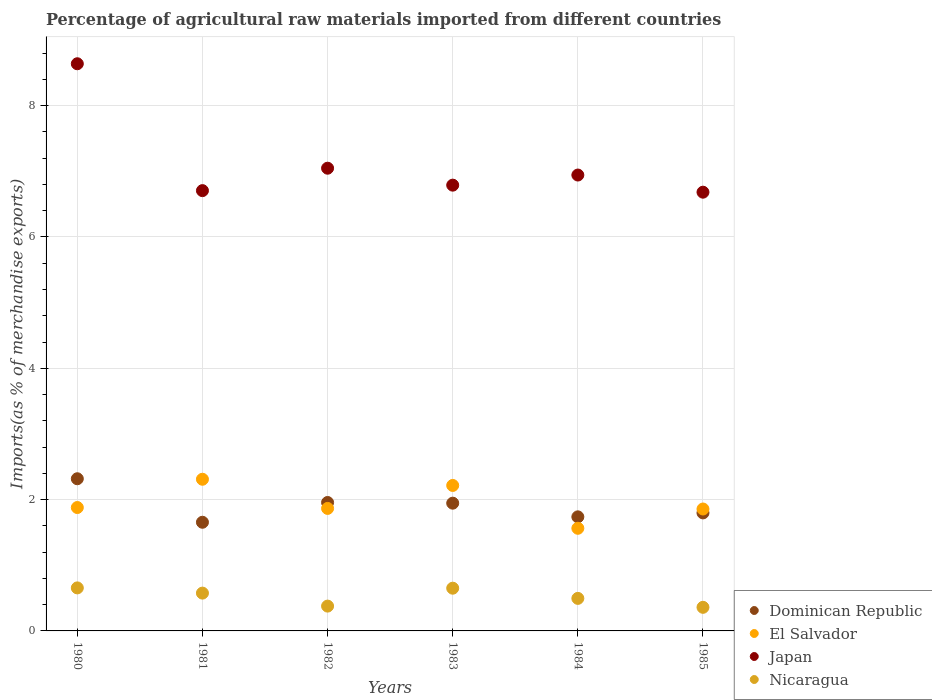Is the number of dotlines equal to the number of legend labels?
Provide a short and direct response. Yes. What is the percentage of imports to different countries in Japan in 1983?
Give a very brief answer. 6.79. Across all years, what is the maximum percentage of imports to different countries in Dominican Republic?
Offer a very short reply. 2.32. Across all years, what is the minimum percentage of imports to different countries in Nicaragua?
Make the answer very short. 0.36. What is the total percentage of imports to different countries in Japan in the graph?
Give a very brief answer. 42.8. What is the difference between the percentage of imports to different countries in El Salvador in 1982 and that in 1984?
Provide a short and direct response. 0.3. What is the difference between the percentage of imports to different countries in Nicaragua in 1983 and the percentage of imports to different countries in El Salvador in 1982?
Your response must be concise. -1.21. What is the average percentage of imports to different countries in Nicaragua per year?
Offer a terse response. 0.52. In the year 1981, what is the difference between the percentage of imports to different countries in El Salvador and percentage of imports to different countries in Dominican Republic?
Provide a succinct answer. 0.65. What is the ratio of the percentage of imports to different countries in Japan in 1981 to that in 1984?
Keep it short and to the point. 0.97. Is the percentage of imports to different countries in El Salvador in 1983 less than that in 1984?
Your answer should be very brief. No. Is the difference between the percentage of imports to different countries in El Salvador in 1980 and 1985 greater than the difference between the percentage of imports to different countries in Dominican Republic in 1980 and 1985?
Ensure brevity in your answer.  No. What is the difference between the highest and the second highest percentage of imports to different countries in Nicaragua?
Ensure brevity in your answer.  0. What is the difference between the highest and the lowest percentage of imports to different countries in Nicaragua?
Your response must be concise. 0.3. In how many years, is the percentage of imports to different countries in El Salvador greater than the average percentage of imports to different countries in El Salvador taken over all years?
Provide a succinct answer. 2. Is it the case that in every year, the sum of the percentage of imports to different countries in El Salvador and percentage of imports to different countries in Japan  is greater than the percentage of imports to different countries in Nicaragua?
Provide a succinct answer. Yes. Is the percentage of imports to different countries in Dominican Republic strictly less than the percentage of imports to different countries in Nicaragua over the years?
Offer a very short reply. No. How many dotlines are there?
Your answer should be very brief. 4. How many years are there in the graph?
Ensure brevity in your answer.  6. Does the graph contain any zero values?
Your answer should be compact. No. Where does the legend appear in the graph?
Your answer should be compact. Bottom right. How are the legend labels stacked?
Keep it short and to the point. Vertical. What is the title of the graph?
Provide a short and direct response. Percentage of agricultural raw materials imported from different countries. Does "High income: nonOECD" appear as one of the legend labels in the graph?
Keep it short and to the point. No. What is the label or title of the Y-axis?
Offer a terse response. Imports(as % of merchandise exports). What is the Imports(as % of merchandise exports) of Dominican Republic in 1980?
Provide a short and direct response. 2.32. What is the Imports(as % of merchandise exports) of El Salvador in 1980?
Offer a terse response. 1.88. What is the Imports(as % of merchandise exports) in Japan in 1980?
Ensure brevity in your answer.  8.64. What is the Imports(as % of merchandise exports) of Nicaragua in 1980?
Keep it short and to the point. 0.66. What is the Imports(as % of merchandise exports) of Dominican Republic in 1981?
Your answer should be compact. 1.65. What is the Imports(as % of merchandise exports) in El Salvador in 1981?
Provide a succinct answer. 2.31. What is the Imports(as % of merchandise exports) of Japan in 1981?
Your response must be concise. 6.71. What is the Imports(as % of merchandise exports) of Nicaragua in 1981?
Keep it short and to the point. 0.58. What is the Imports(as % of merchandise exports) in Dominican Republic in 1982?
Ensure brevity in your answer.  1.96. What is the Imports(as % of merchandise exports) of El Salvador in 1982?
Offer a very short reply. 1.87. What is the Imports(as % of merchandise exports) of Japan in 1982?
Your response must be concise. 7.05. What is the Imports(as % of merchandise exports) in Nicaragua in 1982?
Keep it short and to the point. 0.38. What is the Imports(as % of merchandise exports) in Dominican Republic in 1983?
Provide a short and direct response. 1.95. What is the Imports(as % of merchandise exports) in El Salvador in 1983?
Keep it short and to the point. 2.22. What is the Imports(as % of merchandise exports) of Japan in 1983?
Make the answer very short. 6.79. What is the Imports(as % of merchandise exports) in Nicaragua in 1983?
Your answer should be very brief. 0.65. What is the Imports(as % of merchandise exports) of Dominican Republic in 1984?
Provide a short and direct response. 1.74. What is the Imports(as % of merchandise exports) of El Salvador in 1984?
Your answer should be compact. 1.56. What is the Imports(as % of merchandise exports) in Japan in 1984?
Make the answer very short. 6.94. What is the Imports(as % of merchandise exports) in Nicaragua in 1984?
Your answer should be very brief. 0.5. What is the Imports(as % of merchandise exports) in Dominican Republic in 1985?
Provide a short and direct response. 1.8. What is the Imports(as % of merchandise exports) in El Salvador in 1985?
Your answer should be very brief. 1.86. What is the Imports(as % of merchandise exports) in Japan in 1985?
Give a very brief answer. 6.68. What is the Imports(as % of merchandise exports) of Nicaragua in 1985?
Offer a very short reply. 0.36. Across all years, what is the maximum Imports(as % of merchandise exports) in Dominican Republic?
Your answer should be very brief. 2.32. Across all years, what is the maximum Imports(as % of merchandise exports) of El Salvador?
Keep it short and to the point. 2.31. Across all years, what is the maximum Imports(as % of merchandise exports) of Japan?
Provide a succinct answer. 8.64. Across all years, what is the maximum Imports(as % of merchandise exports) of Nicaragua?
Keep it short and to the point. 0.66. Across all years, what is the minimum Imports(as % of merchandise exports) of Dominican Republic?
Your answer should be compact. 1.65. Across all years, what is the minimum Imports(as % of merchandise exports) in El Salvador?
Offer a terse response. 1.56. Across all years, what is the minimum Imports(as % of merchandise exports) of Japan?
Give a very brief answer. 6.68. Across all years, what is the minimum Imports(as % of merchandise exports) of Nicaragua?
Give a very brief answer. 0.36. What is the total Imports(as % of merchandise exports) of Dominican Republic in the graph?
Your answer should be very brief. 11.41. What is the total Imports(as % of merchandise exports) in El Salvador in the graph?
Your answer should be very brief. 11.69. What is the total Imports(as % of merchandise exports) of Japan in the graph?
Your response must be concise. 42.8. What is the total Imports(as % of merchandise exports) in Nicaragua in the graph?
Provide a succinct answer. 3.11. What is the difference between the Imports(as % of merchandise exports) of Dominican Republic in 1980 and that in 1981?
Provide a succinct answer. 0.66. What is the difference between the Imports(as % of merchandise exports) of El Salvador in 1980 and that in 1981?
Offer a very short reply. -0.43. What is the difference between the Imports(as % of merchandise exports) in Japan in 1980 and that in 1981?
Offer a very short reply. 1.93. What is the difference between the Imports(as % of merchandise exports) of Nicaragua in 1980 and that in 1981?
Your response must be concise. 0.08. What is the difference between the Imports(as % of merchandise exports) in Dominican Republic in 1980 and that in 1982?
Ensure brevity in your answer.  0.36. What is the difference between the Imports(as % of merchandise exports) of El Salvador in 1980 and that in 1982?
Offer a terse response. 0.01. What is the difference between the Imports(as % of merchandise exports) in Japan in 1980 and that in 1982?
Your answer should be very brief. 1.59. What is the difference between the Imports(as % of merchandise exports) in Nicaragua in 1980 and that in 1982?
Give a very brief answer. 0.28. What is the difference between the Imports(as % of merchandise exports) of Dominican Republic in 1980 and that in 1983?
Your answer should be very brief. 0.37. What is the difference between the Imports(as % of merchandise exports) in El Salvador in 1980 and that in 1983?
Offer a terse response. -0.34. What is the difference between the Imports(as % of merchandise exports) of Japan in 1980 and that in 1983?
Offer a very short reply. 1.85. What is the difference between the Imports(as % of merchandise exports) of Nicaragua in 1980 and that in 1983?
Your answer should be compact. 0. What is the difference between the Imports(as % of merchandise exports) of Dominican Republic in 1980 and that in 1984?
Your answer should be compact. 0.58. What is the difference between the Imports(as % of merchandise exports) of El Salvador in 1980 and that in 1984?
Give a very brief answer. 0.32. What is the difference between the Imports(as % of merchandise exports) of Japan in 1980 and that in 1984?
Provide a short and direct response. 1.69. What is the difference between the Imports(as % of merchandise exports) in Nicaragua in 1980 and that in 1984?
Your answer should be compact. 0.16. What is the difference between the Imports(as % of merchandise exports) of Dominican Republic in 1980 and that in 1985?
Offer a terse response. 0.52. What is the difference between the Imports(as % of merchandise exports) of El Salvador in 1980 and that in 1985?
Keep it short and to the point. 0.02. What is the difference between the Imports(as % of merchandise exports) of Japan in 1980 and that in 1985?
Your answer should be very brief. 1.96. What is the difference between the Imports(as % of merchandise exports) in Nicaragua in 1980 and that in 1985?
Provide a succinct answer. 0.3. What is the difference between the Imports(as % of merchandise exports) in Dominican Republic in 1981 and that in 1982?
Your answer should be compact. -0.3. What is the difference between the Imports(as % of merchandise exports) of El Salvador in 1981 and that in 1982?
Provide a succinct answer. 0.44. What is the difference between the Imports(as % of merchandise exports) in Japan in 1981 and that in 1982?
Provide a succinct answer. -0.34. What is the difference between the Imports(as % of merchandise exports) of Nicaragua in 1981 and that in 1982?
Give a very brief answer. 0.2. What is the difference between the Imports(as % of merchandise exports) of Dominican Republic in 1981 and that in 1983?
Offer a terse response. -0.29. What is the difference between the Imports(as % of merchandise exports) of El Salvador in 1981 and that in 1983?
Provide a short and direct response. 0.09. What is the difference between the Imports(as % of merchandise exports) in Japan in 1981 and that in 1983?
Your answer should be very brief. -0.08. What is the difference between the Imports(as % of merchandise exports) in Nicaragua in 1981 and that in 1983?
Your answer should be very brief. -0.07. What is the difference between the Imports(as % of merchandise exports) in Dominican Republic in 1981 and that in 1984?
Make the answer very short. -0.08. What is the difference between the Imports(as % of merchandise exports) of El Salvador in 1981 and that in 1984?
Ensure brevity in your answer.  0.75. What is the difference between the Imports(as % of merchandise exports) of Japan in 1981 and that in 1984?
Provide a succinct answer. -0.24. What is the difference between the Imports(as % of merchandise exports) of Nicaragua in 1981 and that in 1984?
Offer a terse response. 0.08. What is the difference between the Imports(as % of merchandise exports) in Dominican Republic in 1981 and that in 1985?
Your response must be concise. -0.14. What is the difference between the Imports(as % of merchandise exports) in El Salvador in 1981 and that in 1985?
Provide a short and direct response. 0.45. What is the difference between the Imports(as % of merchandise exports) in Japan in 1981 and that in 1985?
Provide a short and direct response. 0.02. What is the difference between the Imports(as % of merchandise exports) in Nicaragua in 1981 and that in 1985?
Make the answer very short. 0.22. What is the difference between the Imports(as % of merchandise exports) of Dominican Republic in 1982 and that in 1983?
Provide a succinct answer. 0.01. What is the difference between the Imports(as % of merchandise exports) in El Salvador in 1982 and that in 1983?
Give a very brief answer. -0.35. What is the difference between the Imports(as % of merchandise exports) in Japan in 1982 and that in 1983?
Make the answer very short. 0.26. What is the difference between the Imports(as % of merchandise exports) in Nicaragua in 1982 and that in 1983?
Offer a very short reply. -0.27. What is the difference between the Imports(as % of merchandise exports) in Dominican Republic in 1982 and that in 1984?
Your response must be concise. 0.22. What is the difference between the Imports(as % of merchandise exports) in El Salvador in 1982 and that in 1984?
Your response must be concise. 0.3. What is the difference between the Imports(as % of merchandise exports) of Japan in 1982 and that in 1984?
Offer a very short reply. 0.1. What is the difference between the Imports(as % of merchandise exports) of Nicaragua in 1982 and that in 1984?
Keep it short and to the point. -0.12. What is the difference between the Imports(as % of merchandise exports) of Dominican Republic in 1982 and that in 1985?
Your answer should be very brief. 0.16. What is the difference between the Imports(as % of merchandise exports) of El Salvador in 1982 and that in 1985?
Make the answer very short. 0.01. What is the difference between the Imports(as % of merchandise exports) of Japan in 1982 and that in 1985?
Your answer should be compact. 0.37. What is the difference between the Imports(as % of merchandise exports) of Nicaragua in 1982 and that in 1985?
Your answer should be compact. 0.02. What is the difference between the Imports(as % of merchandise exports) of Dominican Republic in 1983 and that in 1984?
Offer a very short reply. 0.21. What is the difference between the Imports(as % of merchandise exports) of El Salvador in 1983 and that in 1984?
Offer a terse response. 0.65. What is the difference between the Imports(as % of merchandise exports) in Japan in 1983 and that in 1984?
Provide a succinct answer. -0.15. What is the difference between the Imports(as % of merchandise exports) of Nicaragua in 1983 and that in 1984?
Your answer should be very brief. 0.16. What is the difference between the Imports(as % of merchandise exports) of Dominican Republic in 1983 and that in 1985?
Give a very brief answer. 0.15. What is the difference between the Imports(as % of merchandise exports) of El Salvador in 1983 and that in 1985?
Offer a terse response. 0.36. What is the difference between the Imports(as % of merchandise exports) in Japan in 1983 and that in 1985?
Provide a short and direct response. 0.11. What is the difference between the Imports(as % of merchandise exports) in Nicaragua in 1983 and that in 1985?
Give a very brief answer. 0.29. What is the difference between the Imports(as % of merchandise exports) of Dominican Republic in 1984 and that in 1985?
Keep it short and to the point. -0.06. What is the difference between the Imports(as % of merchandise exports) of El Salvador in 1984 and that in 1985?
Provide a succinct answer. -0.29. What is the difference between the Imports(as % of merchandise exports) in Japan in 1984 and that in 1985?
Your answer should be very brief. 0.26. What is the difference between the Imports(as % of merchandise exports) of Nicaragua in 1984 and that in 1985?
Your answer should be compact. 0.14. What is the difference between the Imports(as % of merchandise exports) in Dominican Republic in 1980 and the Imports(as % of merchandise exports) in El Salvador in 1981?
Keep it short and to the point. 0.01. What is the difference between the Imports(as % of merchandise exports) in Dominican Republic in 1980 and the Imports(as % of merchandise exports) in Japan in 1981?
Make the answer very short. -4.39. What is the difference between the Imports(as % of merchandise exports) of Dominican Republic in 1980 and the Imports(as % of merchandise exports) of Nicaragua in 1981?
Provide a short and direct response. 1.74. What is the difference between the Imports(as % of merchandise exports) of El Salvador in 1980 and the Imports(as % of merchandise exports) of Japan in 1981?
Make the answer very short. -4.83. What is the difference between the Imports(as % of merchandise exports) in El Salvador in 1980 and the Imports(as % of merchandise exports) in Nicaragua in 1981?
Make the answer very short. 1.3. What is the difference between the Imports(as % of merchandise exports) in Japan in 1980 and the Imports(as % of merchandise exports) in Nicaragua in 1981?
Provide a succinct answer. 8.06. What is the difference between the Imports(as % of merchandise exports) in Dominican Republic in 1980 and the Imports(as % of merchandise exports) in El Salvador in 1982?
Provide a succinct answer. 0.45. What is the difference between the Imports(as % of merchandise exports) in Dominican Republic in 1980 and the Imports(as % of merchandise exports) in Japan in 1982?
Ensure brevity in your answer.  -4.73. What is the difference between the Imports(as % of merchandise exports) of Dominican Republic in 1980 and the Imports(as % of merchandise exports) of Nicaragua in 1982?
Keep it short and to the point. 1.94. What is the difference between the Imports(as % of merchandise exports) in El Salvador in 1980 and the Imports(as % of merchandise exports) in Japan in 1982?
Offer a very short reply. -5.17. What is the difference between the Imports(as % of merchandise exports) in El Salvador in 1980 and the Imports(as % of merchandise exports) in Nicaragua in 1982?
Your response must be concise. 1.5. What is the difference between the Imports(as % of merchandise exports) of Japan in 1980 and the Imports(as % of merchandise exports) of Nicaragua in 1982?
Offer a terse response. 8.26. What is the difference between the Imports(as % of merchandise exports) of Dominican Republic in 1980 and the Imports(as % of merchandise exports) of El Salvador in 1983?
Make the answer very short. 0.1. What is the difference between the Imports(as % of merchandise exports) in Dominican Republic in 1980 and the Imports(as % of merchandise exports) in Japan in 1983?
Provide a short and direct response. -4.47. What is the difference between the Imports(as % of merchandise exports) in Dominican Republic in 1980 and the Imports(as % of merchandise exports) in Nicaragua in 1983?
Give a very brief answer. 1.67. What is the difference between the Imports(as % of merchandise exports) in El Salvador in 1980 and the Imports(as % of merchandise exports) in Japan in 1983?
Your response must be concise. -4.91. What is the difference between the Imports(as % of merchandise exports) in El Salvador in 1980 and the Imports(as % of merchandise exports) in Nicaragua in 1983?
Provide a succinct answer. 1.23. What is the difference between the Imports(as % of merchandise exports) of Japan in 1980 and the Imports(as % of merchandise exports) of Nicaragua in 1983?
Give a very brief answer. 7.99. What is the difference between the Imports(as % of merchandise exports) of Dominican Republic in 1980 and the Imports(as % of merchandise exports) of El Salvador in 1984?
Ensure brevity in your answer.  0.75. What is the difference between the Imports(as % of merchandise exports) in Dominican Republic in 1980 and the Imports(as % of merchandise exports) in Japan in 1984?
Provide a short and direct response. -4.63. What is the difference between the Imports(as % of merchandise exports) in Dominican Republic in 1980 and the Imports(as % of merchandise exports) in Nicaragua in 1984?
Your response must be concise. 1.82. What is the difference between the Imports(as % of merchandise exports) of El Salvador in 1980 and the Imports(as % of merchandise exports) of Japan in 1984?
Offer a very short reply. -5.06. What is the difference between the Imports(as % of merchandise exports) of El Salvador in 1980 and the Imports(as % of merchandise exports) of Nicaragua in 1984?
Provide a succinct answer. 1.38. What is the difference between the Imports(as % of merchandise exports) in Japan in 1980 and the Imports(as % of merchandise exports) in Nicaragua in 1984?
Make the answer very short. 8.14. What is the difference between the Imports(as % of merchandise exports) in Dominican Republic in 1980 and the Imports(as % of merchandise exports) in El Salvador in 1985?
Ensure brevity in your answer.  0.46. What is the difference between the Imports(as % of merchandise exports) in Dominican Republic in 1980 and the Imports(as % of merchandise exports) in Japan in 1985?
Provide a succinct answer. -4.36. What is the difference between the Imports(as % of merchandise exports) in Dominican Republic in 1980 and the Imports(as % of merchandise exports) in Nicaragua in 1985?
Keep it short and to the point. 1.96. What is the difference between the Imports(as % of merchandise exports) of El Salvador in 1980 and the Imports(as % of merchandise exports) of Japan in 1985?
Provide a short and direct response. -4.8. What is the difference between the Imports(as % of merchandise exports) in El Salvador in 1980 and the Imports(as % of merchandise exports) in Nicaragua in 1985?
Your response must be concise. 1.52. What is the difference between the Imports(as % of merchandise exports) in Japan in 1980 and the Imports(as % of merchandise exports) in Nicaragua in 1985?
Your answer should be compact. 8.28. What is the difference between the Imports(as % of merchandise exports) in Dominican Republic in 1981 and the Imports(as % of merchandise exports) in El Salvador in 1982?
Make the answer very short. -0.21. What is the difference between the Imports(as % of merchandise exports) of Dominican Republic in 1981 and the Imports(as % of merchandise exports) of Japan in 1982?
Offer a very short reply. -5.39. What is the difference between the Imports(as % of merchandise exports) in Dominican Republic in 1981 and the Imports(as % of merchandise exports) in Nicaragua in 1982?
Provide a succinct answer. 1.28. What is the difference between the Imports(as % of merchandise exports) of El Salvador in 1981 and the Imports(as % of merchandise exports) of Japan in 1982?
Your answer should be very brief. -4.74. What is the difference between the Imports(as % of merchandise exports) in El Salvador in 1981 and the Imports(as % of merchandise exports) in Nicaragua in 1982?
Provide a succinct answer. 1.93. What is the difference between the Imports(as % of merchandise exports) of Japan in 1981 and the Imports(as % of merchandise exports) of Nicaragua in 1982?
Your answer should be very brief. 6.33. What is the difference between the Imports(as % of merchandise exports) of Dominican Republic in 1981 and the Imports(as % of merchandise exports) of El Salvador in 1983?
Provide a succinct answer. -0.56. What is the difference between the Imports(as % of merchandise exports) in Dominican Republic in 1981 and the Imports(as % of merchandise exports) in Japan in 1983?
Make the answer very short. -5.13. What is the difference between the Imports(as % of merchandise exports) in El Salvador in 1981 and the Imports(as % of merchandise exports) in Japan in 1983?
Your response must be concise. -4.48. What is the difference between the Imports(as % of merchandise exports) in El Salvador in 1981 and the Imports(as % of merchandise exports) in Nicaragua in 1983?
Your response must be concise. 1.66. What is the difference between the Imports(as % of merchandise exports) in Japan in 1981 and the Imports(as % of merchandise exports) in Nicaragua in 1983?
Give a very brief answer. 6.05. What is the difference between the Imports(as % of merchandise exports) in Dominican Republic in 1981 and the Imports(as % of merchandise exports) in El Salvador in 1984?
Provide a succinct answer. 0.09. What is the difference between the Imports(as % of merchandise exports) in Dominican Republic in 1981 and the Imports(as % of merchandise exports) in Japan in 1984?
Your answer should be compact. -5.29. What is the difference between the Imports(as % of merchandise exports) in Dominican Republic in 1981 and the Imports(as % of merchandise exports) in Nicaragua in 1984?
Your answer should be compact. 1.16. What is the difference between the Imports(as % of merchandise exports) in El Salvador in 1981 and the Imports(as % of merchandise exports) in Japan in 1984?
Offer a very short reply. -4.63. What is the difference between the Imports(as % of merchandise exports) in El Salvador in 1981 and the Imports(as % of merchandise exports) in Nicaragua in 1984?
Give a very brief answer. 1.81. What is the difference between the Imports(as % of merchandise exports) in Japan in 1981 and the Imports(as % of merchandise exports) in Nicaragua in 1984?
Your answer should be compact. 6.21. What is the difference between the Imports(as % of merchandise exports) of Dominican Republic in 1981 and the Imports(as % of merchandise exports) of El Salvador in 1985?
Your answer should be compact. -0.2. What is the difference between the Imports(as % of merchandise exports) of Dominican Republic in 1981 and the Imports(as % of merchandise exports) of Japan in 1985?
Provide a succinct answer. -5.03. What is the difference between the Imports(as % of merchandise exports) of Dominican Republic in 1981 and the Imports(as % of merchandise exports) of Nicaragua in 1985?
Your response must be concise. 1.3. What is the difference between the Imports(as % of merchandise exports) in El Salvador in 1981 and the Imports(as % of merchandise exports) in Japan in 1985?
Give a very brief answer. -4.37. What is the difference between the Imports(as % of merchandise exports) of El Salvador in 1981 and the Imports(as % of merchandise exports) of Nicaragua in 1985?
Your response must be concise. 1.95. What is the difference between the Imports(as % of merchandise exports) in Japan in 1981 and the Imports(as % of merchandise exports) in Nicaragua in 1985?
Your response must be concise. 6.35. What is the difference between the Imports(as % of merchandise exports) of Dominican Republic in 1982 and the Imports(as % of merchandise exports) of El Salvador in 1983?
Your answer should be compact. -0.26. What is the difference between the Imports(as % of merchandise exports) of Dominican Republic in 1982 and the Imports(as % of merchandise exports) of Japan in 1983?
Make the answer very short. -4.83. What is the difference between the Imports(as % of merchandise exports) of Dominican Republic in 1982 and the Imports(as % of merchandise exports) of Nicaragua in 1983?
Ensure brevity in your answer.  1.31. What is the difference between the Imports(as % of merchandise exports) in El Salvador in 1982 and the Imports(as % of merchandise exports) in Japan in 1983?
Offer a terse response. -4.92. What is the difference between the Imports(as % of merchandise exports) in El Salvador in 1982 and the Imports(as % of merchandise exports) in Nicaragua in 1983?
Make the answer very short. 1.21. What is the difference between the Imports(as % of merchandise exports) in Japan in 1982 and the Imports(as % of merchandise exports) in Nicaragua in 1983?
Your response must be concise. 6.4. What is the difference between the Imports(as % of merchandise exports) of Dominican Republic in 1982 and the Imports(as % of merchandise exports) of El Salvador in 1984?
Your answer should be very brief. 0.39. What is the difference between the Imports(as % of merchandise exports) in Dominican Republic in 1982 and the Imports(as % of merchandise exports) in Japan in 1984?
Make the answer very short. -4.99. What is the difference between the Imports(as % of merchandise exports) of Dominican Republic in 1982 and the Imports(as % of merchandise exports) of Nicaragua in 1984?
Offer a very short reply. 1.46. What is the difference between the Imports(as % of merchandise exports) of El Salvador in 1982 and the Imports(as % of merchandise exports) of Japan in 1984?
Provide a short and direct response. -5.08. What is the difference between the Imports(as % of merchandise exports) of El Salvador in 1982 and the Imports(as % of merchandise exports) of Nicaragua in 1984?
Offer a terse response. 1.37. What is the difference between the Imports(as % of merchandise exports) of Japan in 1982 and the Imports(as % of merchandise exports) of Nicaragua in 1984?
Offer a terse response. 6.55. What is the difference between the Imports(as % of merchandise exports) in Dominican Republic in 1982 and the Imports(as % of merchandise exports) in El Salvador in 1985?
Offer a very short reply. 0.1. What is the difference between the Imports(as % of merchandise exports) in Dominican Republic in 1982 and the Imports(as % of merchandise exports) in Japan in 1985?
Your response must be concise. -4.73. What is the difference between the Imports(as % of merchandise exports) of Dominican Republic in 1982 and the Imports(as % of merchandise exports) of Nicaragua in 1985?
Provide a short and direct response. 1.6. What is the difference between the Imports(as % of merchandise exports) in El Salvador in 1982 and the Imports(as % of merchandise exports) in Japan in 1985?
Keep it short and to the point. -4.82. What is the difference between the Imports(as % of merchandise exports) of El Salvador in 1982 and the Imports(as % of merchandise exports) of Nicaragua in 1985?
Your answer should be compact. 1.51. What is the difference between the Imports(as % of merchandise exports) of Japan in 1982 and the Imports(as % of merchandise exports) of Nicaragua in 1985?
Give a very brief answer. 6.69. What is the difference between the Imports(as % of merchandise exports) in Dominican Republic in 1983 and the Imports(as % of merchandise exports) in El Salvador in 1984?
Your answer should be very brief. 0.38. What is the difference between the Imports(as % of merchandise exports) in Dominican Republic in 1983 and the Imports(as % of merchandise exports) in Japan in 1984?
Your answer should be very brief. -5. What is the difference between the Imports(as % of merchandise exports) in Dominican Republic in 1983 and the Imports(as % of merchandise exports) in Nicaragua in 1984?
Your answer should be very brief. 1.45. What is the difference between the Imports(as % of merchandise exports) of El Salvador in 1983 and the Imports(as % of merchandise exports) of Japan in 1984?
Your response must be concise. -4.73. What is the difference between the Imports(as % of merchandise exports) of El Salvador in 1983 and the Imports(as % of merchandise exports) of Nicaragua in 1984?
Offer a terse response. 1.72. What is the difference between the Imports(as % of merchandise exports) of Japan in 1983 and the Imports(as % of merchandise exports) of Nicaragua in 1984?
Ensure brevity in your answer.  6.29. What is the difference between the Imports(as % of merchandise exports) of Dominican Republic in 1983 and the Imports(as % of merchandise exports) of El Salvador in 1985?
Offer a terse response. 0.09. What is the difference between the Imports(as % of merchandise exports) of Dominican Republic in 1983 and the Imports(as % of merchandise exports) of Japan in 1985?
Offer a terse response. -4.74. What is the difference between the Imports(as % of merchandise exports) of Dominican Republic in 1983 and the Imports(as % of merchandise exports) of Nicaragua in 1985?
Your answer should be compact. 1.59. What is the difference between the Imports(as % of merchandise exports) in El Salvador in 1983 and the Imports(as % of merchandise exports) in Japan in 1985?
Offer a very short reply. -4.47. What is the difference between the Imports(as % of merchandise exports) in El Salvador in 1983 and the Imports(as % of merchandise exports) in Nicaragua in 1985?
Ensure brevity in your answer.  1.86. What is the difference between the Imports(as % of merchandise exports) in Japan in 1983 and the Imports(as % of merchandise exports) in Nicaragua in 1985?
Offer a very short reply. 6.43. What is the difference between the Imports(as % of merchandise exports) in Dominican Republic in 1984 and the Imports(as % of merchandise exports) in El Salvador in 1985?
Give a very brief answer. -0.12. What is the difference between the Imports(as % of merchandise exports) in Dominican Republic in 1984 and the Imports(as % of merchandise exports) in Japan in 1985?
Offer a very short reply. -4.94. What is the difference between the Imports(as % of merchandise exports) of Dominican Republic in 1984 and the Imports(as % of merchandise exports) of Nicaragua in 1985?
Offer a very short reply. 1.38. What is the difference between the Imports(as % of merchandise exports) of El Salvador in 1984 and the Imports(as % of merchandise exports) of Japan in 1985?
Keep it short and to the point. -5.12. What is the difference between the Imports(as % of merchandise exports) of El Salvador in 1984 and the Imports(as % of merchandise exports) of Nicaragua in 1985?
Provide a succinct answer. 1.2. What is the difference between the Imports(as % of merchandise exports) of Japan in 1984 and the Imports(as % of merchandise exports) of Nicaragua in 1985?
Keep it short and to the point. 6.58. What is the average Imports(as % of merchandise exports) of Dominican Republic per year?
Your answer should be compact. 1.9. What is the average Imports(as % of merchandise exports) in El Salvador per year?
Provide a succinct answer. 1.95. What is the average Imports(as % of merchandise exports) in Japan per year?
Offer a very short reply. 7.13. What is the average Imports(as % of merchandise exports) of Nicaragua per year?
Offer a terse response. 0.52. In the year 1980, what is the difference between the Imports(as % of merchandise exports) of Dominican Republic and Imports(as % of merchandise exports) of El Salvador?
Keep it short and to the point. 0.44. In the year 1980, what is the difference between the Imports(as % of merchandise exports) of Dominican Republic and Imports(as % of merchandise exports) of Japan?
Give a very brief answer. -6.32. In the year 1980, what is the difference between the Imports(as % of merchandise exports) of Dominican Republic and Imports(as % of merchandise exports) of Nicaragua?
Ensure brevity in your answer.  1.66. In the year 1980, what is the difference between the Imports(as % of merchandise exports) of El Salvador and Imports(as % of merchandise exports) of Japan?
Make the answer very short. -6.76. In the year 1980, what is the difference between the Imports(as % of merchandise exports) in El Salvador and Imports(as % of merchandise exports) in Nicaragua?
Make the answer very short. 1.22. In the year 1980, what is the difference between the Imports(as % of merchandise exports) in Japan and Imports(as % of merchandise exports) in Nicaragua?
Offer a terse response. 7.98. In the year 1981, what is the difference between the Imports(as % of merchandise exports) of Dominican Republic and Imports(as % of merchandise exports) of El Salvador?
Offer a terse response. -0.66. In the year 1981, what is the difference between the Imports(as % of merchandise exports) in Dominican Republic and Imports(as % of merchandise exports) in Japan?
Provide a succinct answer. -5.05. In the year 1981, what is the difference between the Imports(as % of merchandise exports) of Dominican Republic and Imports(as % of merchandise exports) of Nicaragua?
Make the answer very short. 1.08. In the year 1981, what is the difference between the Imports(as % of merchandise exports) in El Salvador and Imports(as % of merchandise exports) in Japan?
Make the answer very short. -4.4. In the year 1981, what is the difference between the Imports(as % of merchandise exports) of El Salvador and Imports(as % of merchandise exports) of Nicaragua?
Provide a short and direct response. 1.73. In the year 1981, what is the difference between the Imports(as % of merchandise exports) of Japan and Imports(as % of merchandise exports) of Nicaragua?
Your answer should be compact. 6.13. In the year 1982, what is the difference between the Imports(as % of merchandise exports) in Dominican Republic and Imports(as % of merchandise exports) in El Salvador?
Offer a very short reply. 0.09. In the year 1982, what is the difference between the Imports(as % of merchandise exports) in Dominican Republic and Imports(as % of merchandise exports) in Japan?
Your answer should be compact. -5.09. In the year 1982, what is the difference between the Imports(as % of merchandise exports) in Dominican Republic and Imports(as % of merchandise exports) in Nicaragua?
Provide a succinct answer. 1.58. In the year 1982, what is the difference between the Imports(as % of merchandise exports) of El Salvador and Imports(as % of merchandise exports) of Japan?
Ensure brevity in your answer.  -5.18. In the year 1982, what is the difference between the Imports(as % of merchandise exports) in El Salvador and Imports(as % of merchandise exports) in Nicaragua?
Make the answer very short. 1.49. In the year 1982, what is the difference between the Imports(as % of merchandise exports) of Japan and Imports(as % of merchandise exports) of Nicaragua?
Your response must be concise. 6.67. In the year 1983, what is the difference between the Imports(as % of merchandise exports) in Dominican Republic and Imports(as % of merchandise exports) in El Salvador?
Offer a very short reply. -0.27. In the year 1983, what is the difference between the Imports(as % of merchandise exports) in Dominican Republic and Imports(as % of merchandise exports) in Japan?
Make the answer very short. -4.84. In the year 1983, what is the difference between the Imports(as % of merchandise exports) in Dominican Republic and Imports(as % of merchandise exports) in Nicaragua?
Your response must be concise. 1.29. In the year 1983, what is the difference between the Imports(as % of merchandise exports) in El Salvador and Imports(as % of merchandise exports) in Japan?
Keep it short and to the point. -4.57. In the year 1983, what is the difference between the Imports(as % of merchandise exports) of El Salvador and Imports(as % of merchandise exports) of Nicaragua?
Ensure brevity in your answer.  1.56. In the year 1983, what is the difference between the Imports(as % of merchandise exports) of Japan and Imports(as % of merchandise exports) of Nicaragua?
Your answer should be very brief. 6.14. In the year 1984, what is the difference between the Imports(as % of merchandise exports) in Dominican Republic and Imports(as % of merchandise exports) in El Salvador?
Provide a short and direct response. 0.17. In the year 1984, what is the difference between the Imports(as % of merchandise exports) of Dominican Republic and Imports(as % of merchandise exports) of Japan?
Offer a very short reply. -5.21. In the year 1984, what is the difference between the Imports(as % of merchandise exports) of Dominican Republic and Imports(as % of merchandise exports) of Nicaragua?
Offer a very short reply. 1.24. In the year 1984, what is the difference between the Imports(as % of merchandise exports) of El Salvador and Imports(as % of merchandise exports) of Japan?
Your response must be concise. -5.38. In the year 1984, what is the difference between the Imports(as % of merchandise exports) of El Salvador and Imports(as % of merchandise exports) of Nicaragua?
Keep it short and to the point. 1.07. In the year 1984, what is the difference between the Imports(as % of merchandise exports) in Japan and Imports(as % of merchandise exports) in Nicaragua?
Ensure brevity in your answer.  6.45. In the year 1985, what is the difference between the Imports(as % of merchandise exports) in Dominican Republic and Imports(as % of merchandise exports) in El Salvador?
Offer a terse response. -0.06. In the year 1985, what is the difference between the Imports(as % of merchandise exports) in Dominican Republic and Imports(as % of merchandise exports) in Japan?
Give a very brief answer. -4.88. In the year 1985, what is the difference between the Imports(as % of merchandise exports) of Dominican Republic and Imports(as % of merchandise exports) of Nicaragua?
Make the answer very short. 1.44. In the year 1985, what is the difference between the Imports(as % of merchandise exports) in El Salvador and Imports(as % of merchandise exports) in Japan?
Offer a terse response. -4.82. In the year 1985, what is the difference between the Imports(as % of merchandise exports) in El Salvador and Imports(as % of merchandise exports) in Nicaragua?
Give a very brief answer. 1.5. In the year 1985, what is the difference between the Imports(as % of merchandise exports) of Japan and Imports(as % of merchandise exports) of Nicaragua?
Offer a terse response. 6.32. What is the ratio of the Imports(as % of merchandise exports) of Dominican Republic in 1980 to that in 1981?
Provide a short and direct response. 1.4. What is the ratio of the Imports(as % of merchandise exports) of El Salvador in 1980 to that in 1981?
Your answer should be very brief. 0.81. What is the ratio of the Imports(as % of merchandise exports) in Japan in 1980 to that in 1981?
Ensure brevity in your answer.  1.29. What is the ratio of the Imports(as % of merchandise exports) in Nicaragua in 1980 to that in 1981?
Give a very brief answer. 1.14. What is the ratio of the Imports(as % of merchandise exports) in Dominican Republic in 1980 to that in 1982?
Provide a short and direct response. 1.18. What is the ratio of the Imports(as % of merchandise exports) of El Salvador in 1980 to that in 1982?
Give a very brief answer. 1.01. What is the ratio of the Imports(as % of merchandise exports) of Japan in 1980 to that in 1982?
Your response must be concise. 1.23. What is the ratio of the Imports(as % of merchandise exports) of Nicaragua in 1980 to that in 1982?
Offer a very short reply. 1.73. What is the ratio of the Imports(as % of merchandise exports) of Dominican Republic in 1980 to that in 1983?
Give a very brief answer. 1.19. What is the ratio of the Imports(as % of merchandise exports) of El Salvador in 1980 to that in 1983?
Provide a short and direct response. 0.85. What is the ratio of the Imports(as % of merchandise exports) of Japan in 1980 to that in 1983?
Your response must be concise. 1.27. What is the ratio of the Imports(as % of merchandise exports) of Nicaragua in 1980 to that in 1983?
Ensure brevity in your answer.  1.01. What is the ratio of the Imports(as % of merchandise exports) of Dominican Republic in 1980 to that in 1984?
Ensure brevity in your answer.  1.33. What is the ratio of the Imports(as % of merchandise exports) in El Salvador in 1980 to that in 1984?
Provide a succinct answer. 1.2. What is the ratio of the Imports(as % of merchandise exports) in Japan in 1980 to that in 1984?
Offer a very short reply. 1.24. What is the ratio of the Imports(as % of merchandise exports) in Nicaragua in 1980 to that in 1984?
Provide a short and direct response. 1.32. What is the ratio of the Imports(as % of merchandise exports) in Dominican Republic in 1980 to that in 1985?
Your answer should be very brief. 1.29. What is the ratio of the Imports(as % of merchandise exports) of El Salvador in 1980 to that in 1985?
Your answer should be very brief. 1.01. What is the ratio of the Imports(as % of merchandise exports) in Japan in 1980 to that in 1985?
Ensure brevity in your answer.  1.29. What is the ratio of the Imports(as % of merchandise exports) in Nicaragua in 1980 to that in 1985?
Offer a terse response. 1.82. What is the ratio of the Imports(as % of merchandise exports) of Dominican Republic in 1981 to that in 1982?
Your answer should be compact. 0.85. What is the ratio of the Imports(as % of merchandise exports) in El Salvador in 1981 to that in 1982?
Offer a very short reply. 1.24. What is the ratio of the Imports(as % of merchandise exports) of Japan in 1981 to that in 1982?
Your answer should be compact. 0.95. What is the ratio of the Imports(as % of merchandise exports) in Nicaragua in 1981 to that in 1982?
Your answer should be very brief. 1.52. What is the ratio of the Imports(as % of merchandise exports) of Dominican Republic in 1981 to that in 1983?
Provide a succinct answer. 0.85. What is the ratio of the Imports(as % of merchandise exports) in El Salvador in 1981 to that in 1983?
Your response must be concise. 1.04. What is the ratio of the Imports(as % of merchandise exports) in Nicaragua in 1981 to that in 1983?
Your response must be concise. 0.88. What is the ratio of the Imports(as % of merchandise exports) in Dominican Republic in 1981 to that in 1984?
Make the answer very short. 0.95. What is the ratio of the Imports(as % of merchandise exports) in El Salvador in 1981 to that in 1984?
Make the answer very short. 1.48. What is the ratio of the Imports(as % of merchandise exports) in Japan in 1981 to that in 1984?
Give a very brief answer. 0.97. What is the ratio of the Imports(as % of merchandise exports) of Nicaragua in 1981 to that in 1984?
Provide a short and direct response. 1.16. What is the ratio of the Imports(as % of merchandise exports) of Dominican Republic in 1981 to that in 1985?
Give a very brief answer. 0.92. What is the ratio of the Imports(as % of merchandise exports) in El Salvador in 1981 to that in 1985?
Keep it short and to the point. 1.24. What is the ratio of the Imports(as % of merchandise exports) of Japan in 1981 to that in 1985?
Make the answer very short. 1. What is the ratio of the Imports(as % of merchandise exports) of Nicaragua in 1981 to that in 1985?
Give a very brief answer. 1.6. What is the ratio of the Imports(as % of merchandise exports) in Dominican Republic in 1982 to that in 1983?
Your answer should be very brief. 1.01. What is the ratio of the Imports(as % of merchandise exports) of El Salvador in 1982 to that in 1983?
Your response must be concise. 0.84. What is the ratio of the Imports(as % of merchandise exports) of Japan in 1982 to that in 1983?
Ensure brevity in your answer.  1.04. What is the ratio of the Imports(as % of merchandise exports) in Nicaragua in 1982 to that in 1983?
Your response must be concise. 0.58. What is the ratio of the Imports(as % of merchandise exports) of Dominican Republic in 1982 to that in 1984?
Ensure brevity in your answer.  1.13. What is the ratio of the Imports(as % of merchandise exports) of El Salvador in 1982 to that in 1984?
Provide a succinct answer. 1.19. What is the ratio of the Imports(as % of merchandise exports) of Nicaragua in 1982 to that in 1984?
Your answer should be compact. 0.76. What is the ratio of the Imports(as % of merchandise exports) in Dominican Republic in 1982 to that in 1985?
Offer a very short reply. 1.09. What is the ratio of the Imports(as % of merchandise exports) in Japan in 1982 to that in 1985?
Offer a very short reply. 1.05. What is the ratio of the Imports(as % of merchandise exports) of Nicaragua in 1982 to that in 1985?
Ensure brevity in your answer.  1.05. What is the ratio of the Imports(as % of merchandise exports) in Dominican Republic in 1983 to that in 1984?
Your answer should be compact. 1.12. What is the ratio of the Imports(as % of merchandise exports) in El Salvador in 1983 to that in 1984?
Provide a short and direct response. 1.42. What is the ratio of the Imports(as % of merchandise exports) of Japan in 1983 to that in 1984?
Give a very brief answer. 0.98. What is the ratio of the Imports(as % of merchandise exports) of Nicaragua in 1983 to that in 1984?
Ensure brevity in your answer.  1.31. What is the ratio of the Imports(as % of merchandise exports) of Dominican Republic in 1983 to that in 1985?
Give a very brief answer. 1.08. What is the ratio of the Imports(as % of merchandise exports) in El Salvador in 1983 to that in 1985?
Your response must be concise. 1.19. What is the ratio of the Imports(as % of merchandise exports) in Nicaragua in 1983 to that in 1985?
Ensure brevity in your answer.  1.81. What is the ratio of the Imports(as % of merchandise exports) of Dominican Republic in 1984 to that in 1985?
Offer a terse response. 0.97. What is the ratio of the Imports(as % of merchandise exports) of El Salvador in 1984 to that in 1985?
Provide a short and direct response. 0.84. What is the ratio of the Imports(as % of merchandise exports) of Japan in 1984 to that in 1985?
Offer a terse response. 1.04. What is the ratio of the Imports(as % of merchandise exports) in Nicaragua in 1984 to that in 1985?
Your answer should be compact. 1.38. What is the difference between the highest and the second highest Imports(as % of merchandise exports) in Dominican Republic?
Ensure brevity in your answer.  0.36. What is the difference between the highest and the second highest Imports(as % of merchandise exports) of El Salvador?
Give a very brief answer. 0.09. What is the difference between the highest and the second highest Imports(as % of merchandise exports) of Japan?
Provide a short and direct response. 1.59. What is the difference between the highest and the second highest Imports(as % of merchandise exports) in Nicaragua?
Give a very brief answer. 0. What is the difference between the highest and the lowest Imports(as % of merchandise exports) of Dominican Republic?
Provide a short and direct response. 0.66. What is the difference between the highest and the lowest Imports(as % of merchandise exports) of El Salvador?
Offer a terse response. 0.75. What is the difference between the highest and the lowest Imports(as % of merchandise exports) in Japan?
Give a very brief answer. 1.96. What is the difference between the highest and the lowest Imports(as % of merchandise exports) in Nicaragua?
Offer a terse response. 0.3. 